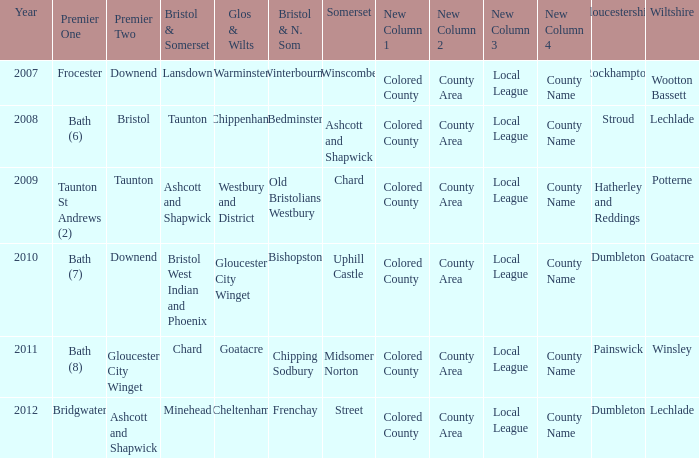What is the latest year where glos & wilts is warminster? 2007.0. 